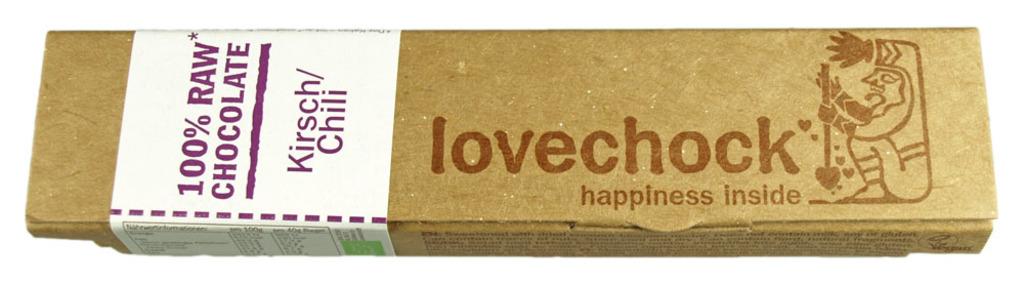What flavor chocolate is this?
Ensure brevity in your answer.  Chili. What percent is this chocolate?
Give a very brief answer. 100. 